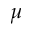<formula> <loc_0><loc_0><loc_500><loc_500>\mu</formula> 